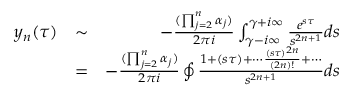<formula> <loc_0><loc_0><loc_500><loc_500>\begin{array} { r l r } { y _ { n } ( \tau ) } & { \sim } & { - \frac { ( \prod _ { j = 2 } ^ { n } \alpha _ { j } ) } { 2 \pi i } \int _ { \gamma - i \infty } ^ { \gamma + i \infty } \frac { e ^ { s \tau } } { s ^ { 2 n + 1 } } d s } \\ & { = } & { - \frac { ( \prod _ { j = 2 } ^ { n } \alpha _ { j } ) } { 2 \pi i } \oint \frac { 1 + ( s \tau ) + \cdots \frac { ( s \tau ) ^ { 2 n } } { ( 2 n ) ! } + \cdots } { s ^ { 2 n + 1 } } d s } \end{array}</formula> 